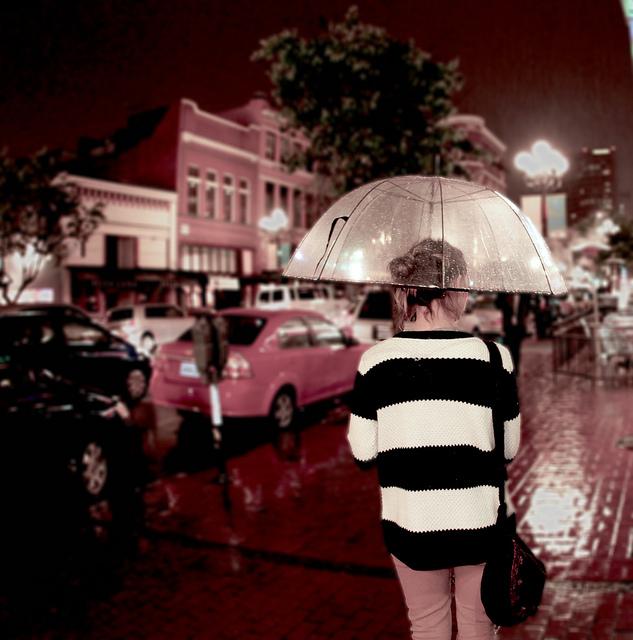Is this photo filtered?
Give a very brief answer. Yes. Is it a rainy night?
Answer briefly. Yes. What is the woman holding over the head?
Answer briefly. Umbrella. 